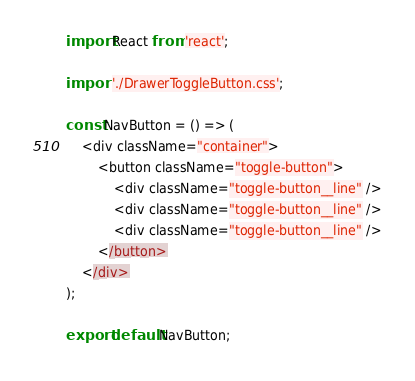<code> <loc_0><loc_0><loc_500><loc_500><_JavaScript_>import React from 'react';

import './DrawerToggleButton.css';

const NavButton = () => (
    <div className="container">
        <button className="toggle-button">
            <div className="toggle-button__line" />
            <div className="toggle-button__line" />
            <div className="toggle-button__line" />
        </button>
    </div>
);

export default NavButton;</code> 